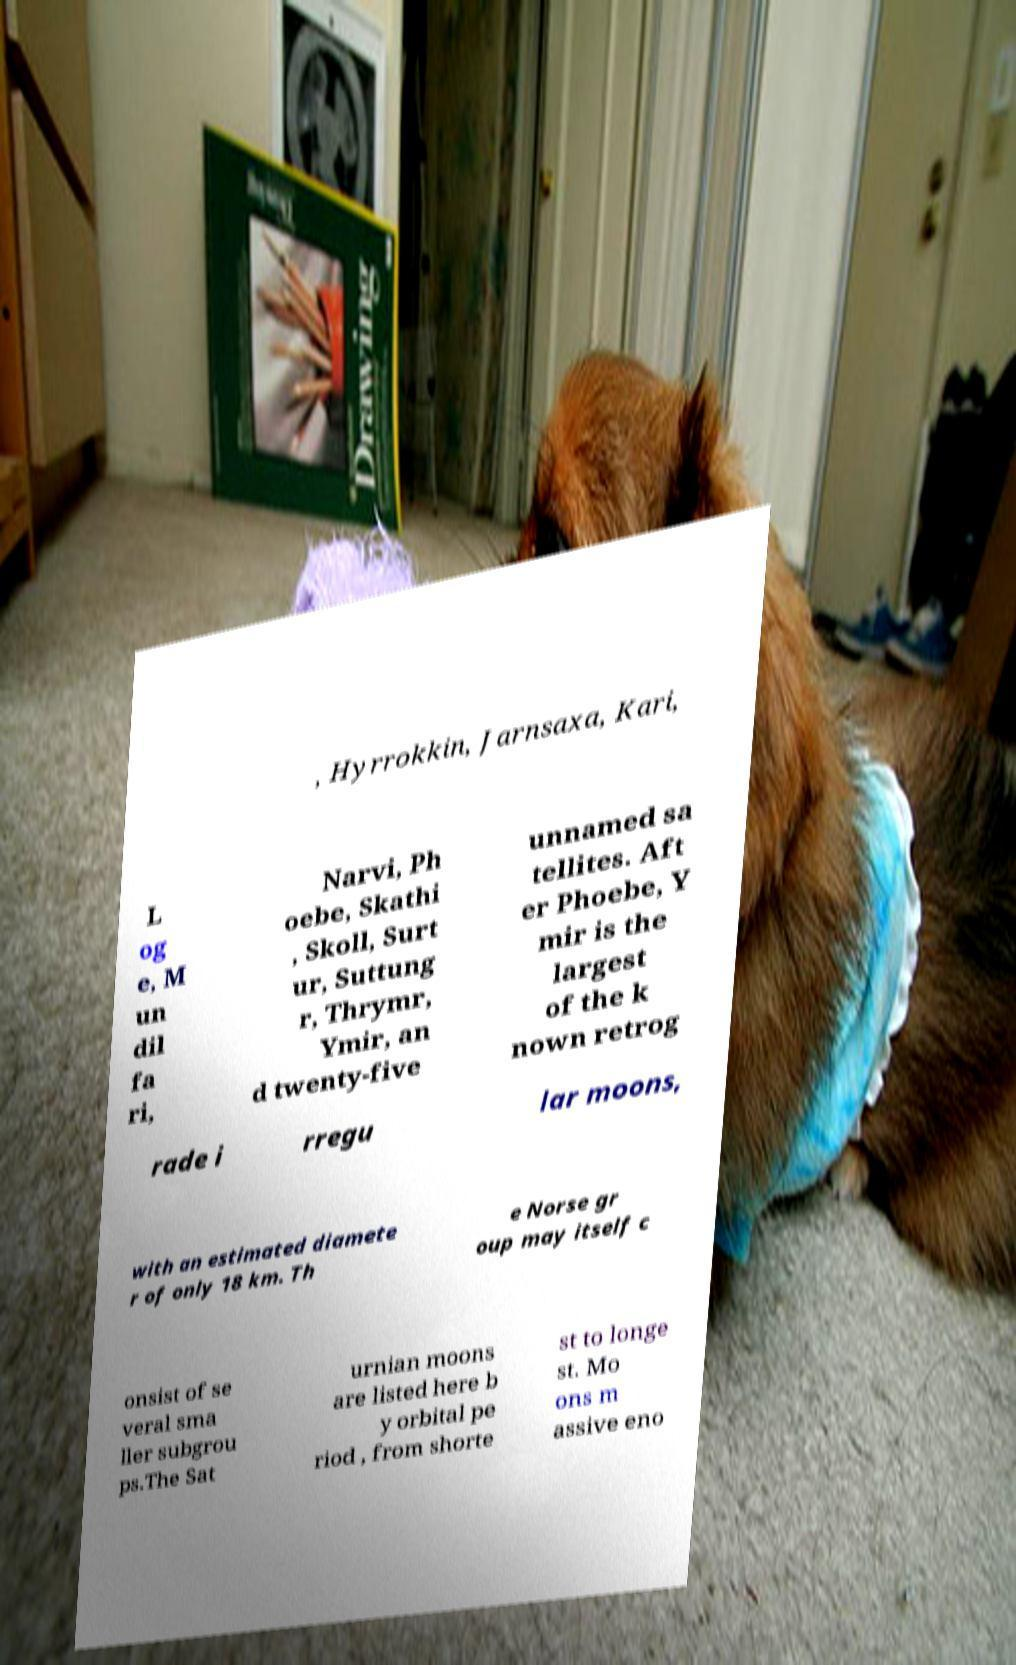Could you extract and type out the text from this image? , Hyrrokkin, Jarnsaxa, Kari, L og e, M un dil fa ri, Narvi, Ph oebe, Skathi , Skoll, Surt ur, Suttung r, Thrymr, Ymir, an d twenty-five unnamed sa tellites. Aft er Phoebe, Y mir is the largest of the k nown retrog rade i rregu lar moons, with an estimated diamete r of only 18 km. Th e Norse gr oup may itself c onsist of se veral sma ller subgrou ps.The Sat urnian moons are listed here b y orbital pe riod , from shorte st to longe st. Mo ons m assive eno 